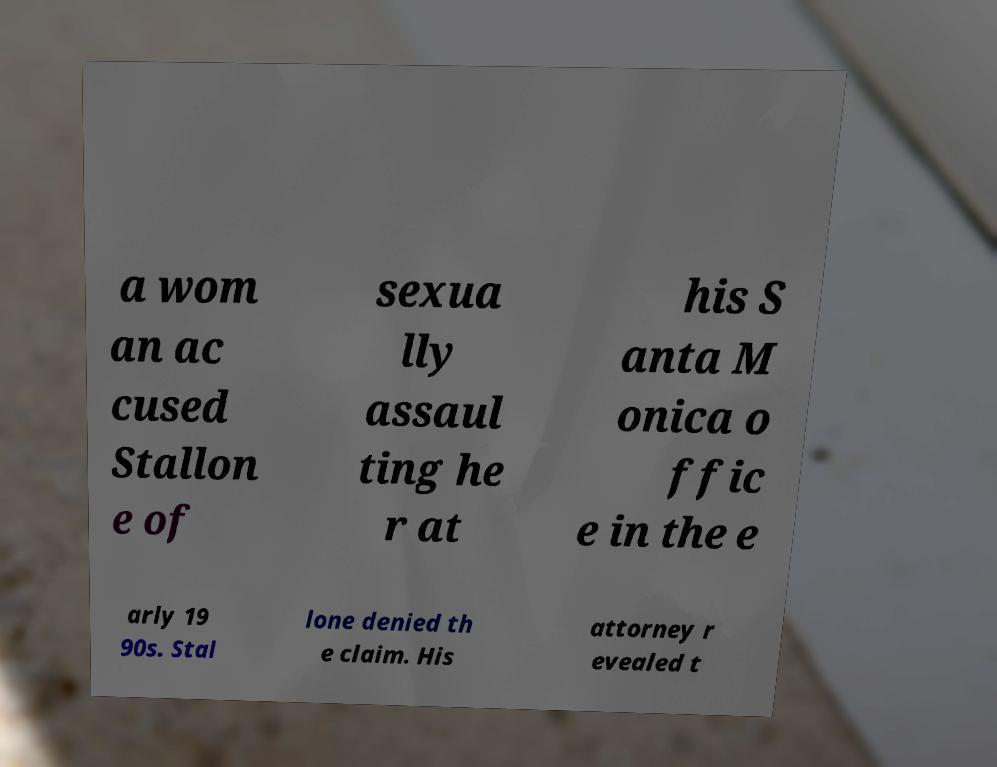What messages or text are displayed in this image? I need them in a readable, typed format. a wom an ac cused Stallon e of sexua lly assaul ting he r at his S anta M onica o ffic e in the e arly 19 90s. Stal lone denied th e claim. His attorney r evealed t 